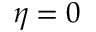Convert formula to latex. <formula><loc_0><loc_0><loc_500><loc_500>\eta = 0</formula> 